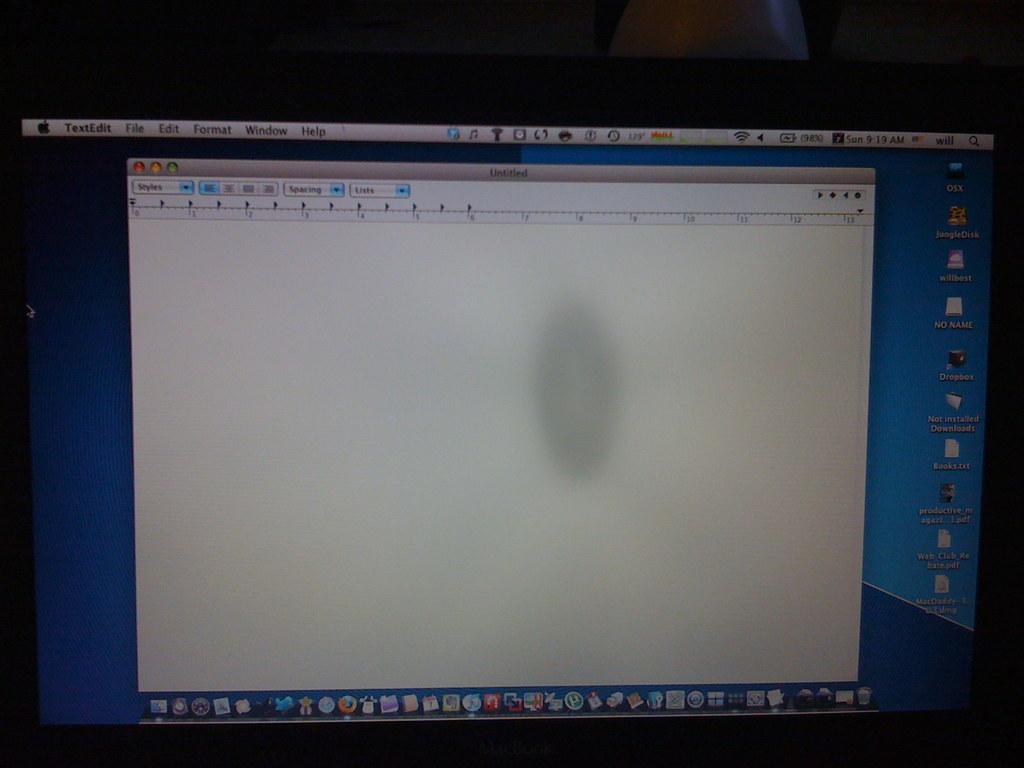What kind of program is being used?
Your answer should be very brief. Textedit. What's the first word you can see from the top left?
Provide a succinct answer. Textedit. 